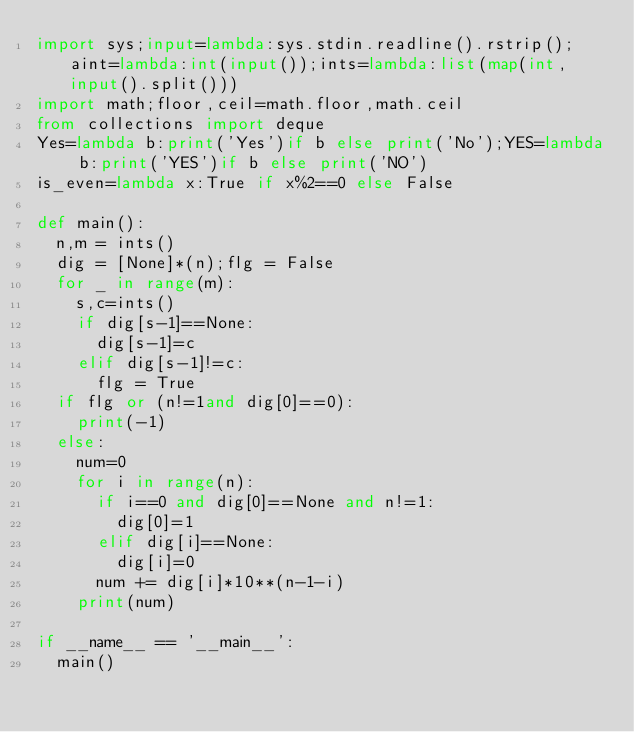<code> <loc_0><loc_0><loc_500><loc_500><_Python_>import sys;input=lambda:sys.stdin.readline().rstrip();aint=lambda:int(input());ints=lambda:list(map(int,input().split()))
import math;floor,ceil=math.floor,math.ceil
from collections import deque
Yes=lambda b:print('Yes')if b else print('No');YES=lambda b:print('YES')if b else print('NO')
is_even=lambda x:True if x%2==0 else False

def main():
  n,m = ints()
  dig = [None]*(n);flg = False
  for _ in range(m):
    s,c=ints()
    if dig[s-1]==None:
      dig[s-1]=c
    elif dig[s-1]!=c:
      flg = True
  if flg or (n!=1and dig[0]==0):
    print(-1)
  else:
    num=0
    for i in range(n):
      if i==0 and dig[0]==None and n!=1:
        dig[0]=1
      elif dig[i]==None:
        dig[i]=0
      num += dig[i]*10**(n-1-i)
    print(num)
      
if __name__ == '__main__':
  main()</code> 